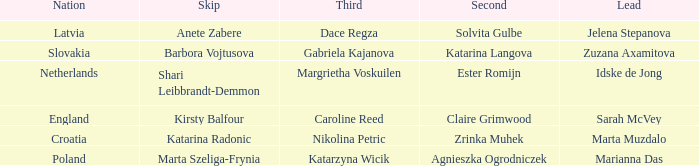Which lead has Kirsty Balfour as second? Sarah McVey. 